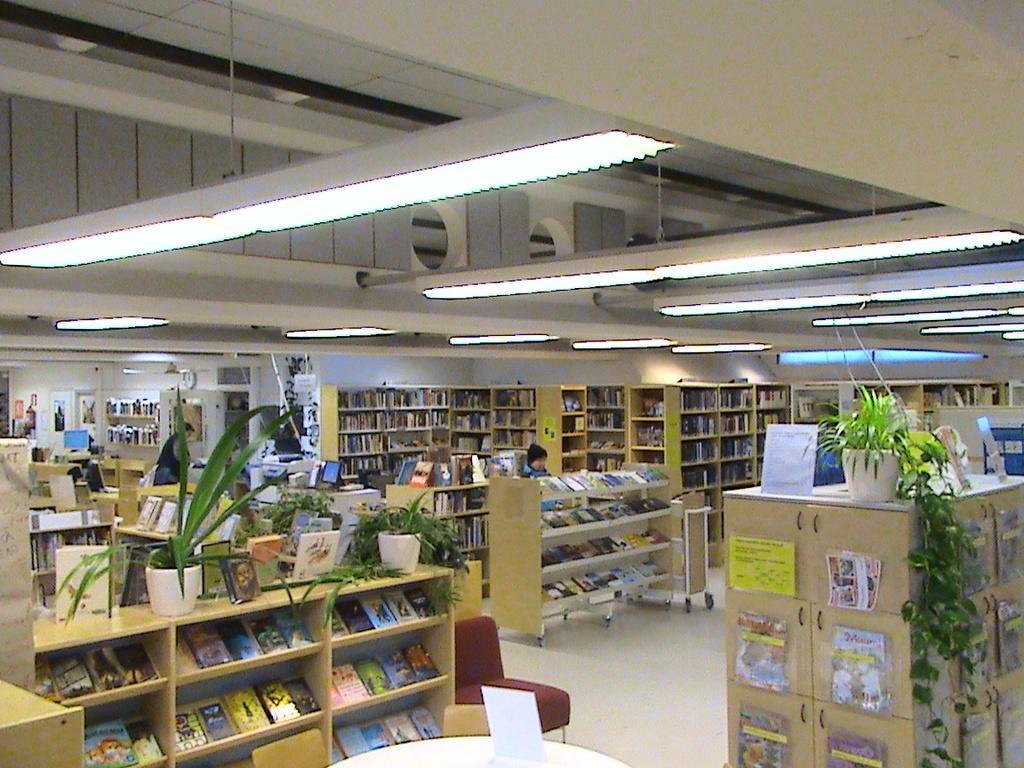How would you summarize this image in a sentence or two? In this image, I can see the books, which are kept in the racks. These are the flower pots with plants, which are kept above the racks. I can see the lights hanging to the ceiling. There are two people and the computers. At the bottom of the image, I can see a board on the table and a chair on the floor. 